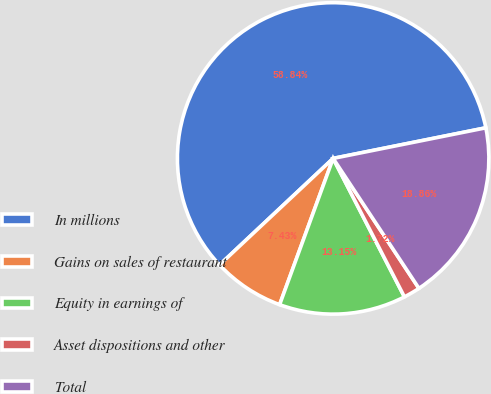Convert chart to OTSL. <chart><loc_0><loc_0><loc_500><loc_500><pie_chart><fcel>In millions<fcel>Gains on sales of restaurant<fcel>Equity in earnings of<fcel>Asset dispositions and other<fcel>Total<nl><fcel>58.84%<fcel>7.43%<fcel>13.15%<fcel>1.72%<fcel>18.86%<nl></chart> 